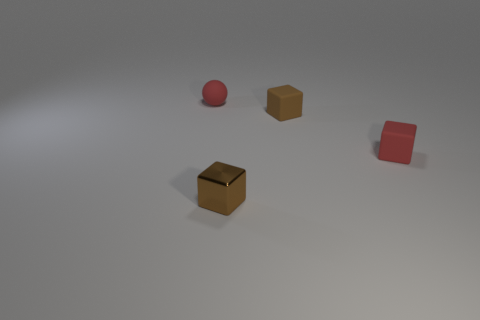Add 3 brown metal blocks. How many objects exist? 7 Subtract all small red cubes. How many cubes are left? 2 Subtract all blue cylinders. How many red blocks are left? 1 Subtract all red cubes. How many cubes are left? 2 Subtract 1 red balls. How many objects are left? 3 Subtract all cubes. How many objects are left? 1 Subtract all cyan balls. Subtract all green cylinders. How many balls are left? 1 Subtract all large blocks. Subtract all rubber cubes. How many objects are left? 2 Add 4 small brown blocks. How many small brown blocks are left? 6 Add 1 rubber things. How many rubber things exist? 4 